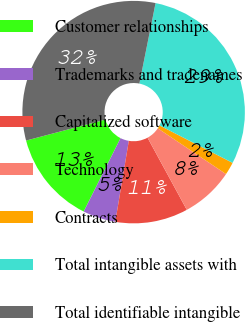Convert chart. <chart><loc_0><loc_0><loc_500><loc_500><pie_chart><fcel>Customer relationships<fcel>Trademarks and tradenames<fcel>Capitalized software<fcel>Technology<fcel>Contracts<fcel>Total intangible assets with<fcel>Total identifiable intangible<nl><fcel>13.48%<fcel>4.77%<fcel>10.57%<fcel>7.67%<fcel>1.86%<fcel>29.38%<fcel>32.28%<nl></chart> 